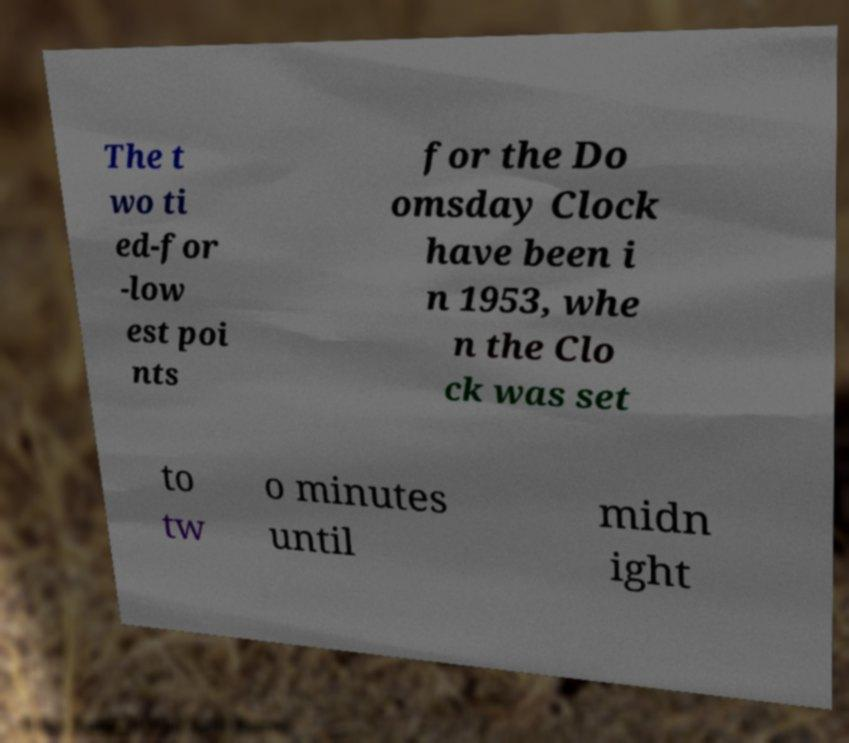For documentation purposes, I need the text within this image transcribed. Could you provide that? The t wo ti ed-for -low est poi nts for the Do omsday Clock have been i n 1953, whe n the Clo ck was set to tw o minutes until midn ight 